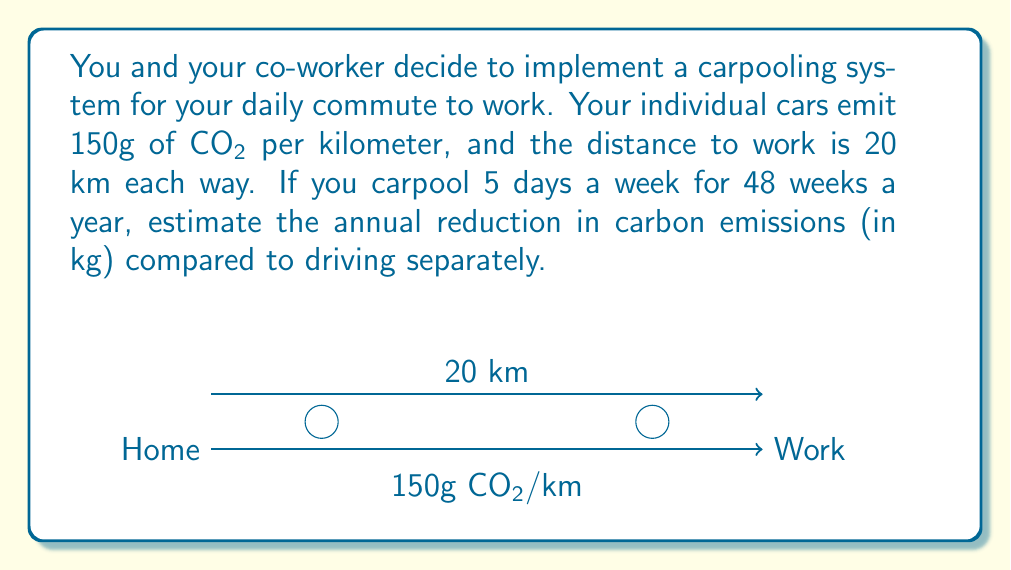Solve this math problem. Let's approach this step-by-step:

1) Calculate the daily round-trip distance:
   $$\text{Daily distance} = 2 \times 20 \text{ km} = 40 \text{ km}$$

2) Calculate the daily emissions for one person:
   $$\text{Daily emissions (one person)} = 40 \text{ km} \times 150 \text{ g/km} = 6000 \text{ g} = 6 \text{ kg}$$

3) Calculate the annual emissions for two people driving separately:
   $$\text{Annual emissions (separate)} = 6 \text{ kg} \times 2 \text{ people} \times 5 \text{ days} \times 48 \text{ weeks} = 2880 \text{ kg}$$

4) With carpooling, only one car is used, so the annual emissions are halved:
   $$\text{Annual emissions (carpooling)} = 6 \text{ kg} \times 1 \text{ car} \times 5 \text{ days} \times 48 \text{ weeks} = 1440 \text{ kg}$$

5) Calculate the reduction in emissions:
   $$\text{Emission reduction} = 2880 \text{ kg} - 1440 \text{ kg} = 1440 \text{ kg}$$

Therefore, the annual reduction in carbon emissions from implementing the carpooling system is 1440 kg of CO₂.
Answer: 1440 kg 